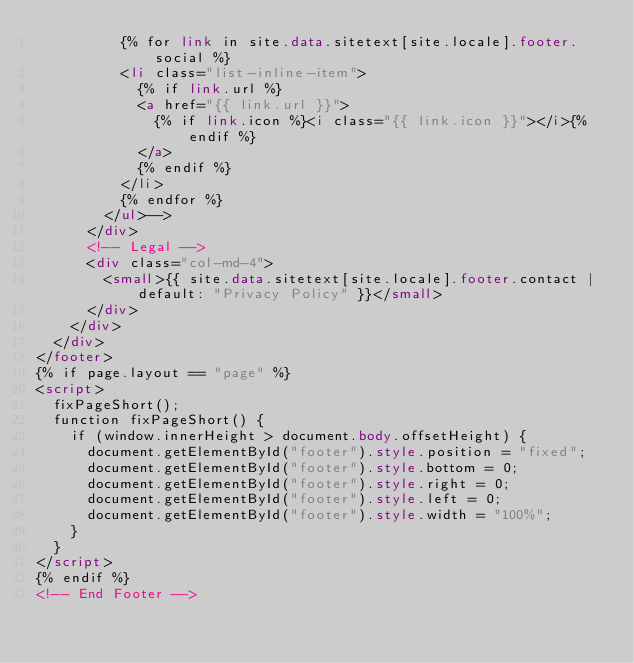<code> <loc_0><loc_0><loc_500><loc_500><_HTML_>          {% for link in site.data.sitetext[site.locale].footer.social %}
          <li class="list-inline-item">
            {% if link.url %}
            <a href="{{ link.url }}">
              {% if link.icon %}<i class="{{ link.icon }}"></i>{% endif %}
            </a>
            {% endif %}
          </li>
          {% endfor %}
        </ul>-->
      </div>
      <!-- Legal -->
      <div class="col-md-4">
        <small>{{ site.data.sitetext[site.locale].footer.contact | default: "Privacy Policy" }}</small>
      </div>
    </div>
  </div>
</footer>
{% if page.layout == "page" %}
<script>
  fixPageShort();
  function fixPageShort() {
    if (window.innerHeight > document.body.offsetHeight) {
      document.getElementById("footer").style.position = "fixed";
      document.getElementById("footer").style.bottom = 0;
      document.getElementById("footer").style.right = 0;
      document.getElementById("footer").style.left = 0;
      document.getElementById("footer").style.width = "100%";
    }
  }
</script>
{% endif %}
<!-- End Footer --></code> 